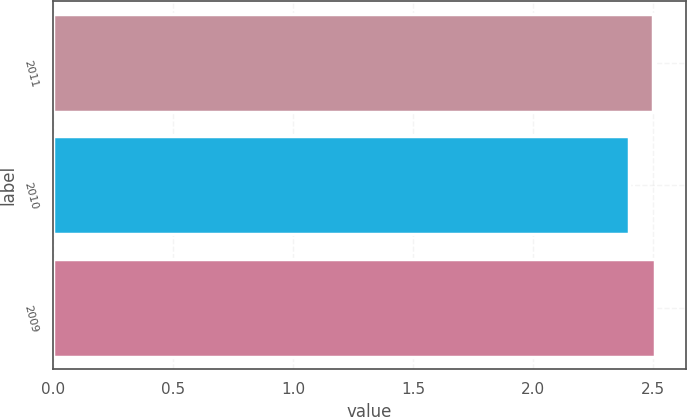<chart> <loc_0><loc_0><loc_500><loc_500><bar_chart><fcel>2011<fcel>2010<fcel>2009<nl><fcel>2.5<fcel>2.4<fcel>2.51<nl></chart> 